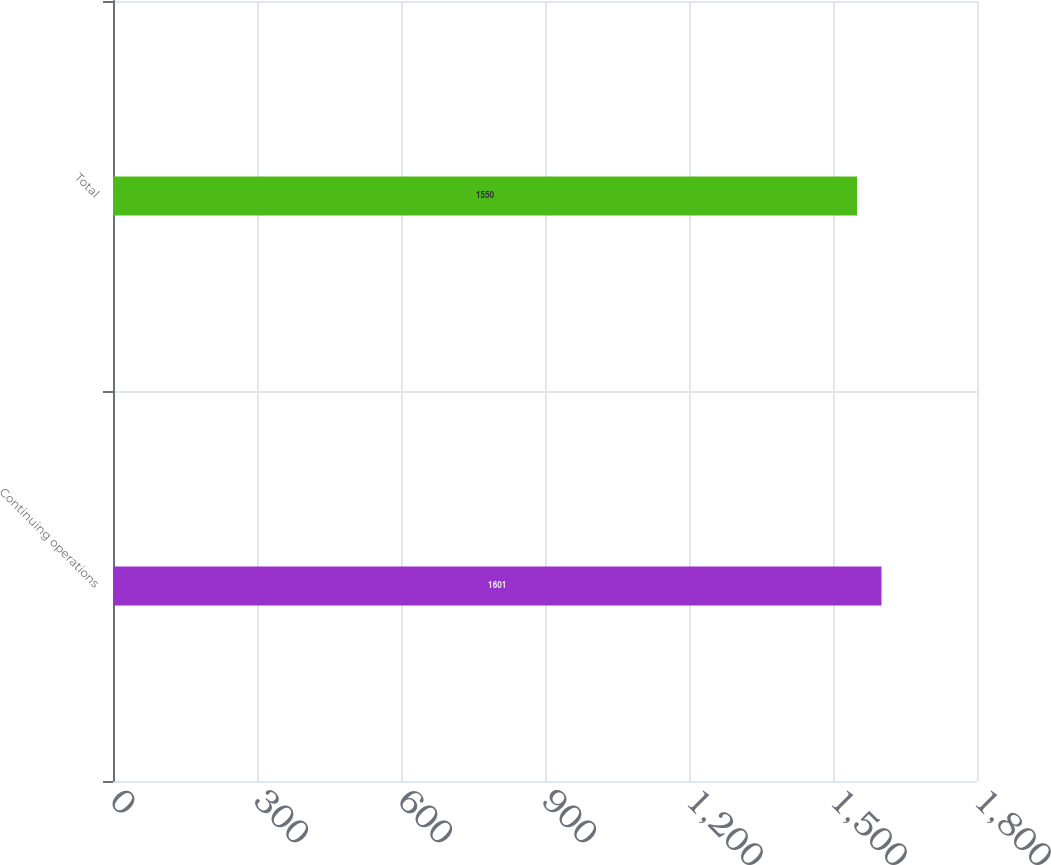Convert chart to OTSL. <chart><loc_0><loc_0><loc_500><loc_500><bar_chart><fcel>Continuing operations<fcel>Total<nl><fcel>1601<fcel>1550<nl></chart> 